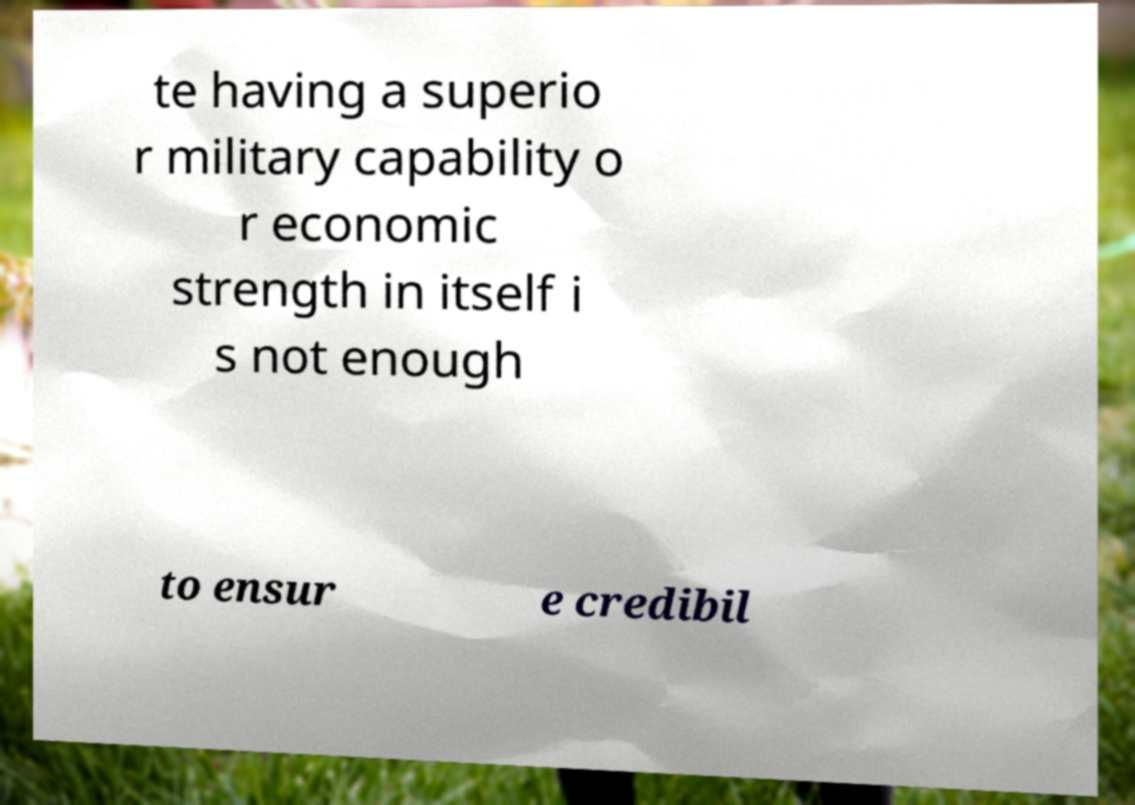Please identify and transcribe the text found in this image. te having a superio r military capability o r economic strength in itself i s not enough to ensur e credibil 